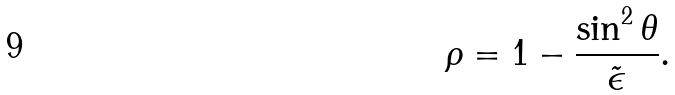<formula> <loc_0><loc_0><loc_500><loc_500>\rho = 1 - \frac { \sin ^ { 2 } \theta } { \tilde { \epsilon } } .</formula> 